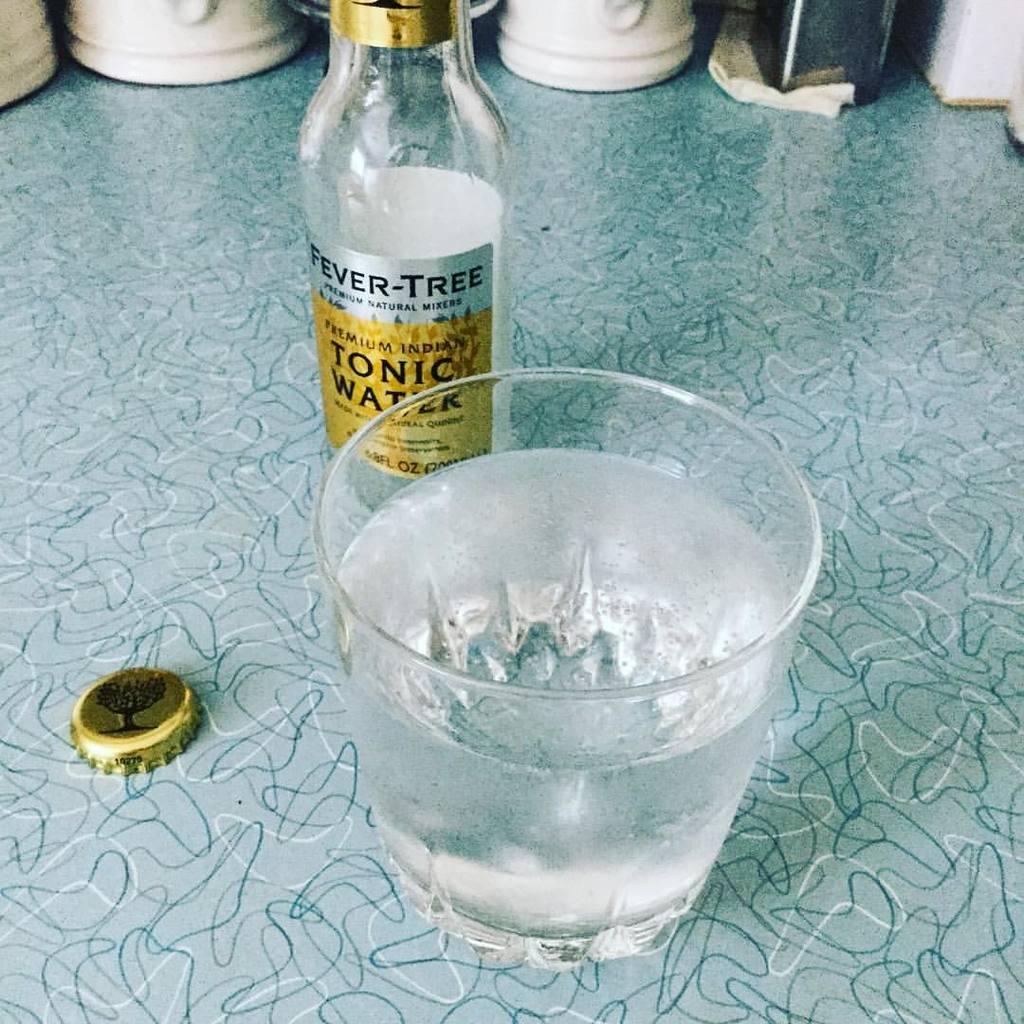Is this tonic water?
Make the answer very short. Yes. 